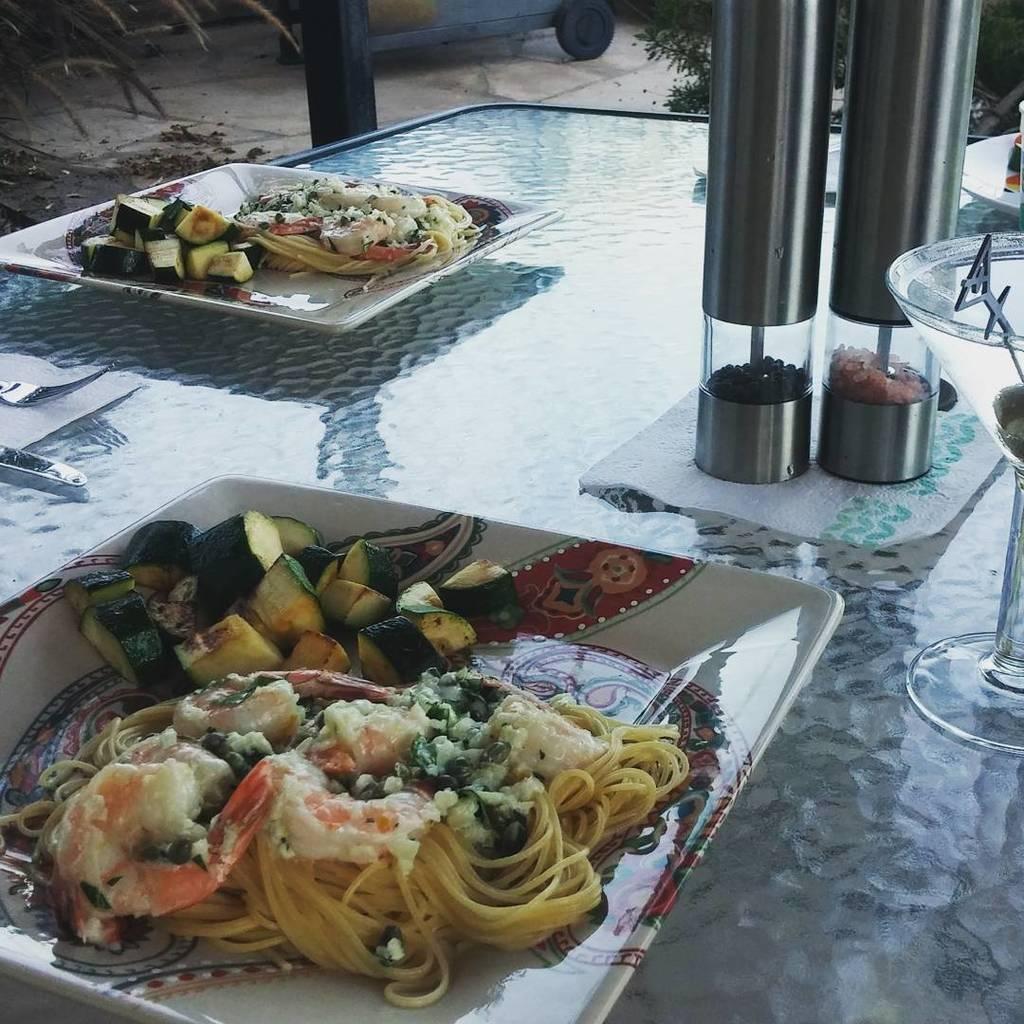Please provide a concise description of this image. In this image there is a table, on which there are plates, glass, bottles, on top plates there is a food item, at the top there is a vehicle, plant, pole. 